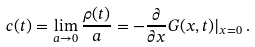<formula> <loc_0><loc_0><loc_500><loc_500>c ( t ) = \lim _ { a \to 0 } \frac { \rho ( t ) } { a } = - \frac { \partial } { \partial x } G ( x , t ) | _ { x = 0 } \, .</formula> 